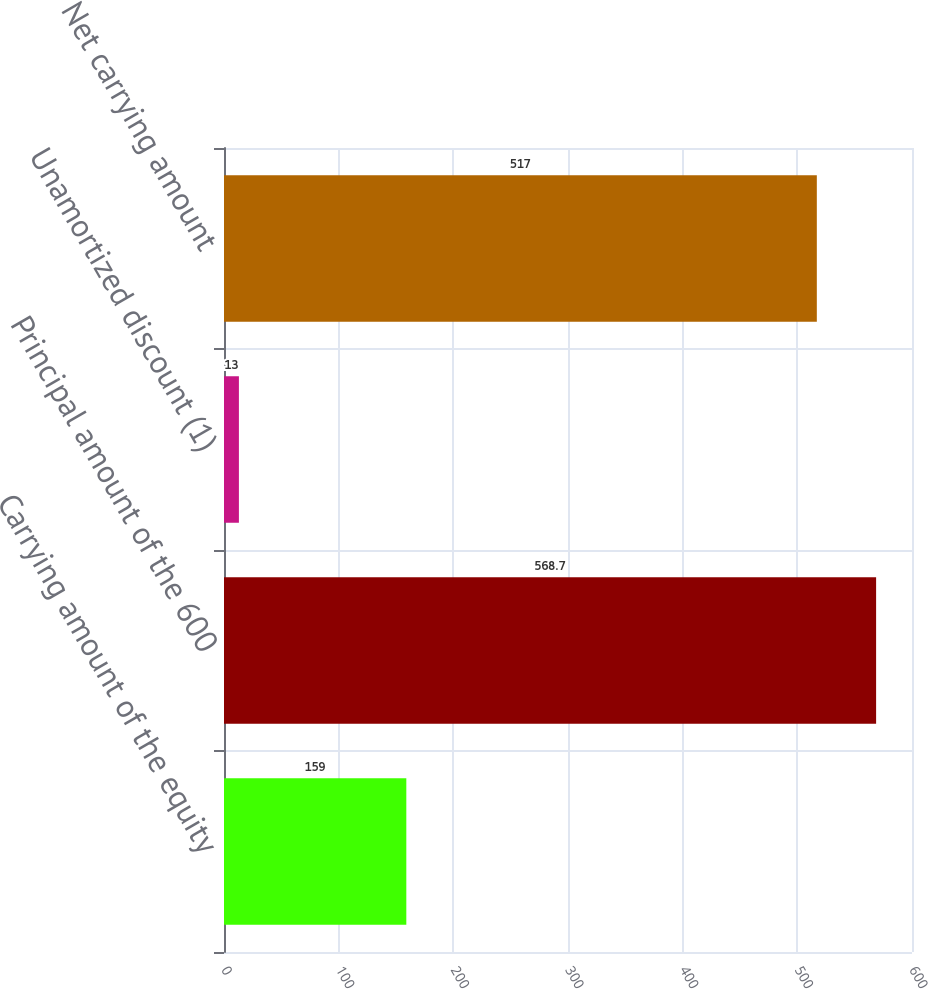Convert chart. <chart><loc_0><loc_0><loc_500><loc_500><bar_chart><fcel>Carrying amount of the equity<fcel>Principal amount of the 600<fcel>Unamortized discount (1)<fcel>Net carrying amount<nl><fcel>159<fcel>568.7<fcel>13<fcel>517<nl></chart> 